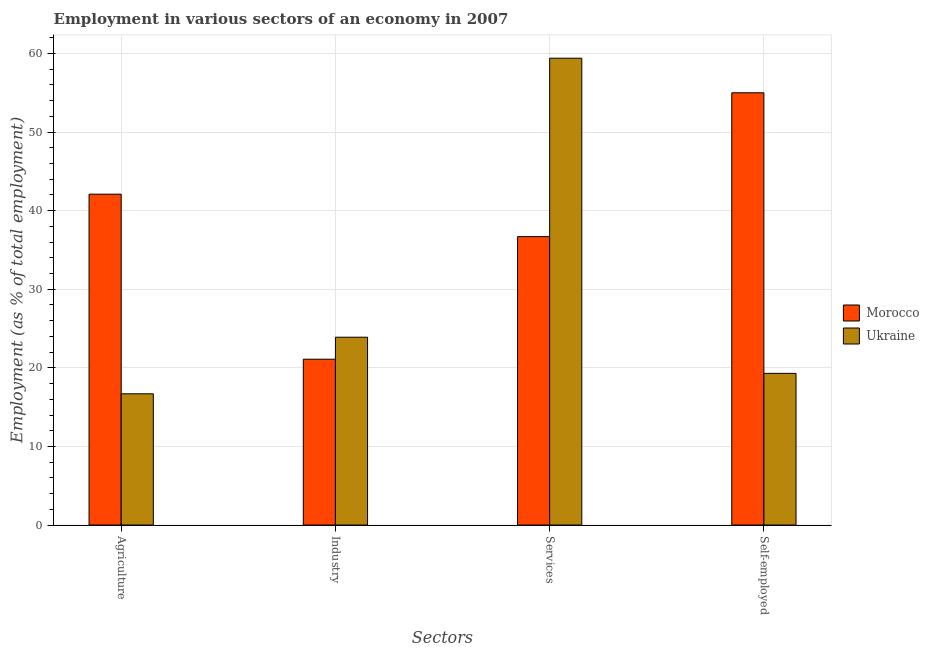Are the number of bars on each tick of the X-axis equal?
Give a very brief answer. Yes. How many bars are there on the 1st tick from the right?
Offer a terse response. 2. What is the label of the 2nd group of bars from the left?
Ensure brevity in your answer.  Industry. What is the percentage of workers in services in Morocco?
Your answer should be very brief. 36.7. Across all countries, what is the maximum percentage of workers in agriculture?
Your answer should be very brief. 42.1. Across all countries, what is the minimum percentage of workers in industry?
Your answer should be compact. 21.1. In which country was the percentage of workers in agriculture maximum?
Provide a short and direct response. Morocco. In which country was the percentage of workers in services minimum?
Give a very brief answer. Morocco. What is the total percentage of workers in agriculture in the graph?
Provide a short and direct response. 58.8. What is the difference between the percentage of workers in services in Ukraine and that in Morocco?
Your answer should be very brief. 22.7. What is the difference between the percentage of self employed workers in Morocco and the percentage of workers in services in Ukraine?
Ensure brevity in your answer.  -4.4. What is the average percentage of workers in agriculture per country?
Offer a very short reply. 29.4. What is the difference between the percentage of workers in agriculture and percentage of self employed workers in Morocco?
Provide a succinct answer. -12.9. In how many countries, is the percentage of self employed workers greater than 38 %?
Your answer should be very brief. 1. What is the ratio of the percentage of self employed workers in Morocco to that in Ukraine?
Your answer should be very brief. 2.85. What is the difference between the highest and the second highest percentage of self employed workers?
Offer a very short reply. 35.7. What is the difference between the highest and the lowest percentage of workers in industry?
Keep it short and to the point. 2.8. Is it the case that in every country, the sum of the percentage of workers in agriculture and percentage of workers in industry is greater than the sum of percentage of self employed workers and percentage of workers in services?
Provide a succinct answer. No. What does the 2nd bar from the left in Self-employed represents?
Keep it short and to the point. Ukraine. What does the 1st bar from the right in Services represents?
Offer a very short reply. Ukraine. Are all the bars in the graph horizontal?
Your answer should be compact. No. What is the difference between two consecutive major ticks on the Y-axis?
Ensure brevity in your answer.  10. Are the values on the major ticks of Y-axis written in scientific E-notation?
Your answer should be very brief. No. Does the graph contain grids?
Ensure brevity in your answer.  Yes. Where does the legend appear in the graph?
Your answer should be very brief. Center right. What is the title of the graph?
Keep it short and to the point. Employment in various sectors of an economy in 2007. Does "Cambodia" appear as one of the legend labels in the graph?
Offer a very short reply. No. What is the label or title of the X-axis?
Offer a terse response. Sectors. What is the label or title of the Y-axis?
Your answer should be very brief. Employment (as % of total employment). What is the Employment (as % of total employment) of Morocco in Agriculture?
Make the answer very short. 42.1. What is the Employment (as % of total employment) of Ukraine in Agriculture?
Offer a terse response. 16.7. What is the Employment (as % of total employment) in Morocco in Industry?
Provide a short and direct response. 21.1. What is the Employment (as % of total employment) of Ukraine in Industry?
Your answer should be very brief. 23.9. What is the Employment (as % of total employment) in Morocco in Services?
Give a very brief answer. 36.7. What is the Employment (as % of total employment) in Ukraine in Services?
Offer a terse response. 59.4. What is the Employment (as % of total employment) in Morocco in Self-employed?
Your response must be concise. 55. What is the Employment (as % of total employment) of Ukraine in Self-employed?
Your response must be concise. 19.3. Across all Sectors, what is the maximum Employment (as % of total employment) in Morocco?
Offer a very short reply. 55. Across all Sectors, what is the maximum Employment (as % of total employment) in Ukraine?
Your response must be concise. 59.4. Across all Sectors, what is the minimum Employment (as % of total employment) in Morocco?
Provide a short and direct response. 21.1. Across all Sectors, what is the minimum Employment (as % of total employment) of Ukraine?
Make the answer very short. 16.7. What is the total Employment (as % of total employment) of Morocco in the graph?
Give a very brief answer. 154.9. What is the total Employment (as % of total employment) of Ukraine in the graph?
Offer a very short reply. 119.3. What is the difference between the Employment (as % of total employment) in Morocco in Agriculture and that in Industry?
Offer a very short reply. 21. What is the difference between the Employment (as % of total employment) of Ukraine in Agriculture and that in Services?
Your response must be concise. -42.7. What is the difference between the Employment (as % of total employment) in Morocco in Agriculture and that in Self-employed?
Your answer should be compact. -12.9. What is the difference between the Employment (as % of total employment) of Morocco in Industry and that in Services?
Offer a terse response. -15.6. What is the difference between the Employment (as % of total employment) of Ukraine in Industry and that in Services?
Keep it short and to the point. -35.5. What is the difference between the Employment (as % of total employment) of Morocco in Industry and that in Self-employed?
Give a very brief answer. -33.9. What is the difference between the Employment (as % of total employment) of Morocco in Services and that in Self-employed?
Your answer should be compact. -18.3. What is the difference between the Employment (as % of total employment) of Ukraine in Services and that in Self-employed?
Your response must be concise. 40.1. What is the difference between the Employment (as % of total employment) in Morocco in Agriculture and the Employment (as % of total employment) in Ukraine in Services?
Give a very brief answer. -17.3. What is the difference between the Employment (as % of total employment) in Morocco in Agriculture and the Employment (as % of total employment) in Ukraine in Self-employed?
Provide a succinct answer. 22.8. What is the difference between the Employment (as % of total employment) in Morocco in Industry and the Employment (as % of total employment) in Ukraine in Services?
Your answer should be very brief. -38.3. What is the difference between the Employment (as % of total employment) in Morocco in Services and the Employment (as % of total employment) in Ukraine in Self-employed?
Give a very brief answer. 17.4. What is the average Employment (as % of total employment) in Morocco per Sectors?
Offer a terse response. 38.73. What is the average Employment (as % of total employment) in Ukraine per Sectors?
Your answer should be very brief. 29.82. What is the difference between the Employment (as % of total employment) of Morocco and Employment (as % of total employment) of Ukraine in Agriculture?
Your answer should be compact. 25.4. What is the difference between the Employment (as % of total employment) in Morocco and Employment (as % of total employment) in Ukraine in Services?
Provide a succinct answer. -22.7. What is the difference between the Employment (as % of total employment) of Morocco and Employment (as % of total employment) of Ukraine in Self-employed?
Offer a very short reply. 35.7. What is the ratio of the Employment (as % of total employment) in Morocco in Agriculture to that in Industry?
Ensure brevity in your answer.  2. What is the ratio of the Employment (as % of total employment) of Ukraine in Agriculture to that in Industry?
Make the answer very short. 0.7. What is the ratio of the Employment (as % of total employment) in Morocco in Agriculture to that in Services?
Your response must be concise. 1.15. What is the ratio of the Employment (as % of total employment) in Ukraine in Agriculture to that in Services?
Provide a succinct answer. 0.28. What is the ratio of the Employment (as % of total employment) in Morocco in Agriculture to that in Self-employed?
Your answer should be very brief. 0.77. What is the ratio of the Employment (as % of total employment) in Ukraine in Agriculture to that in Self-employed?
Offer a terse response. 0.87. What is the ratio of the Employment (as % of total employment) in Morocco in Industry to that in Services?
Provide a short and direct response. 0.57. What is the ratio of the Employment (as % of total employment) in Ukraine in Industry to that in Services?
Provide a short and direct response. 0.4. What is the ratio of the Employment (as % of total employment) in Morocco in Industry to that in Self-employed?
Keep it short and to the point. 0.38. What is the ratio of the Employment (as % of total employment) of Ukraine in Industry to that in Self-employed?
Your answer should be compact. 1.24. What is the ratio of the Employment (as % of total employment) in Morocco in Services to that in Self-employed?
Give a very brief answer. 0.67. What is the ratio of the Employment (as % of total employment) in Ukraine in Services to that in Self-employed?
Your answer should be compact. 3.08. What is the difference between the highest and the second highest Employment (as % of total employment) in Morocco?
Your answer should be compact. 12.9. What is the difference between the highest and the second highest Employment (as % of total employment) in Ukraine?
Provide a short and direct response. 35.5. What is the difference between the highest and the lowest Employment (as % of total employment) of Morocco?
Provide a short and direct response. 33.9. What is the difference between the highest and the lowest Employment (as % of total employment) of Ukraine?
Offer a terse response. 42.7. 